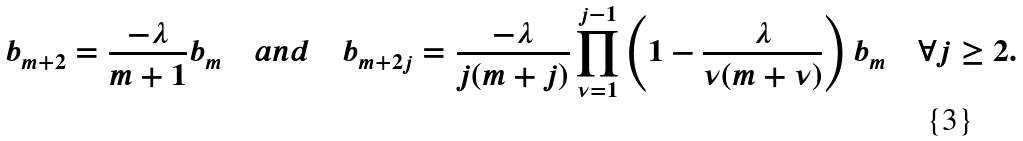<formula> <loc_0><loc_0><loc_500><loc_500>b _ { m + 2 } = \frac { - \lambda } { m + 1 } b _ { m } \quad a n d \quad b _ { m + 2 j } = \frac { - \lambda } { j ( m + j ) } \prod _ { \nu = 1 } ^ { j - 1 } \left ( 1 - \frac { \lambda } { \nu ( m + \nu ) } \right ) b _ { m } \quad \forall j \geq 2 .</formula> 